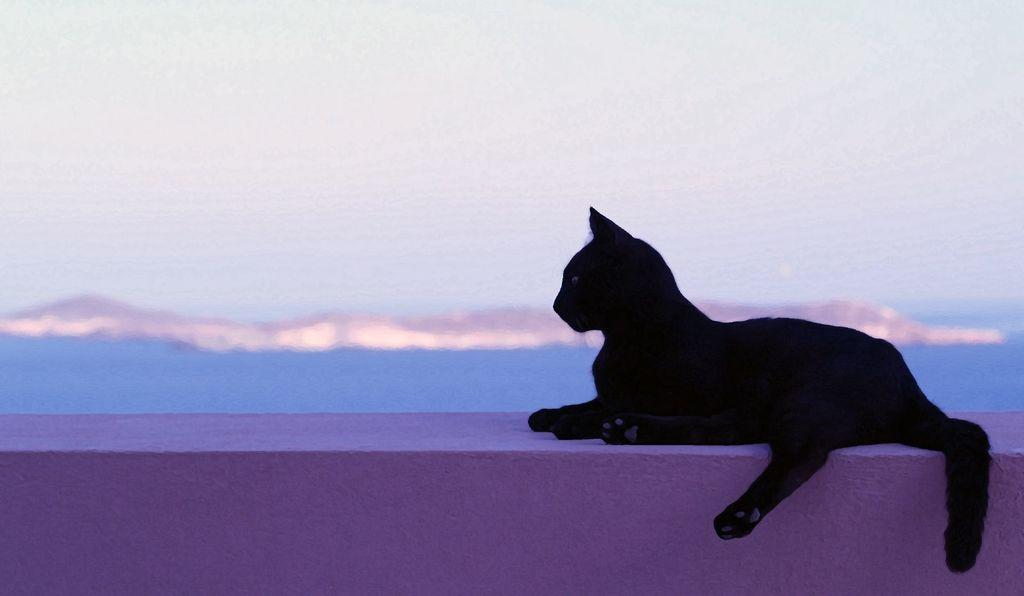What animal can be seen in the picture? There is a black cat in the picture. Where is the cat sitting? The cat is sitting on a pink wall. What natural features can be seen in the background of the image? There is a river and mountains visible in the background of the image. What is visible at the top of the image? The sky is visible at the top of the image. What type of van is parked near the river in the image? There is no van present in the image; it features a black cat sitting on a pink wall with a river and mountains in the background. Is there a beggar visible in the image? There is no beggar present in the image. 